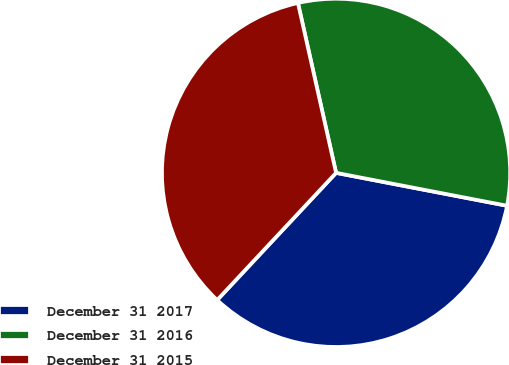Convert chart to OTSL. <chart><loc_0><loc_0><loc_500><loc_500><pie_chart><fcel>December 31 2017<fcel>December 31 2016<fcel>December 31 2015<nl><fcel>33.94%<fcel>31.54%<fcel>34.52%<nl></chart> 